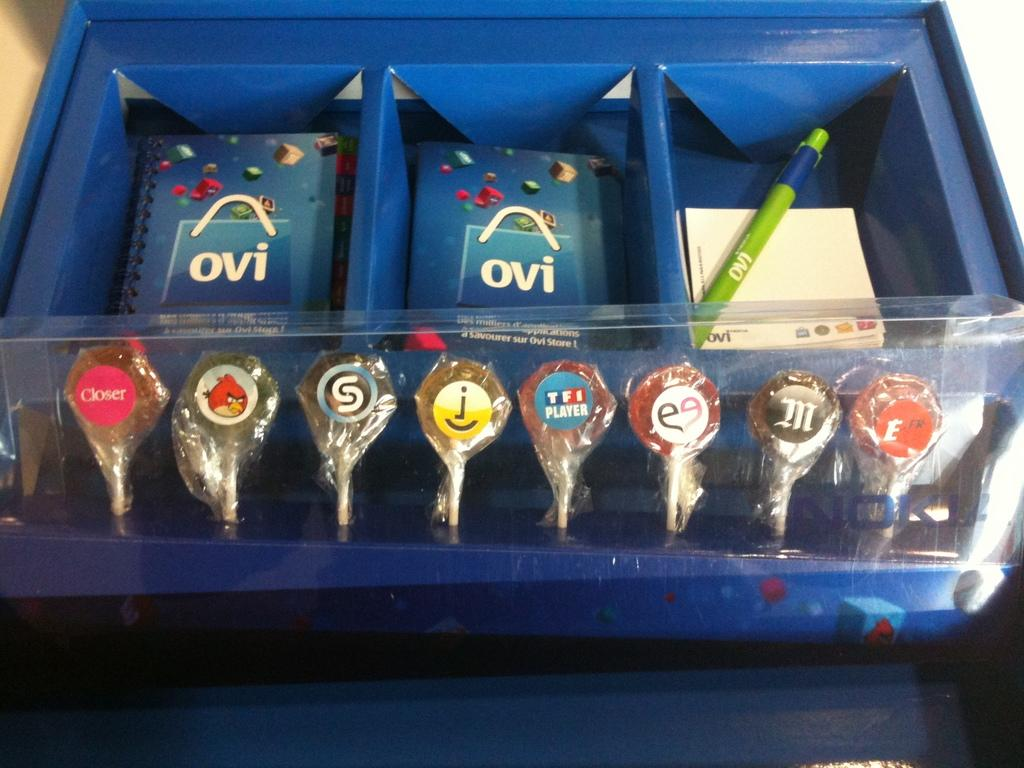Provide a one-sentence caption for the provided image. A blue container with OVI brochures sitting behind lollipops. 